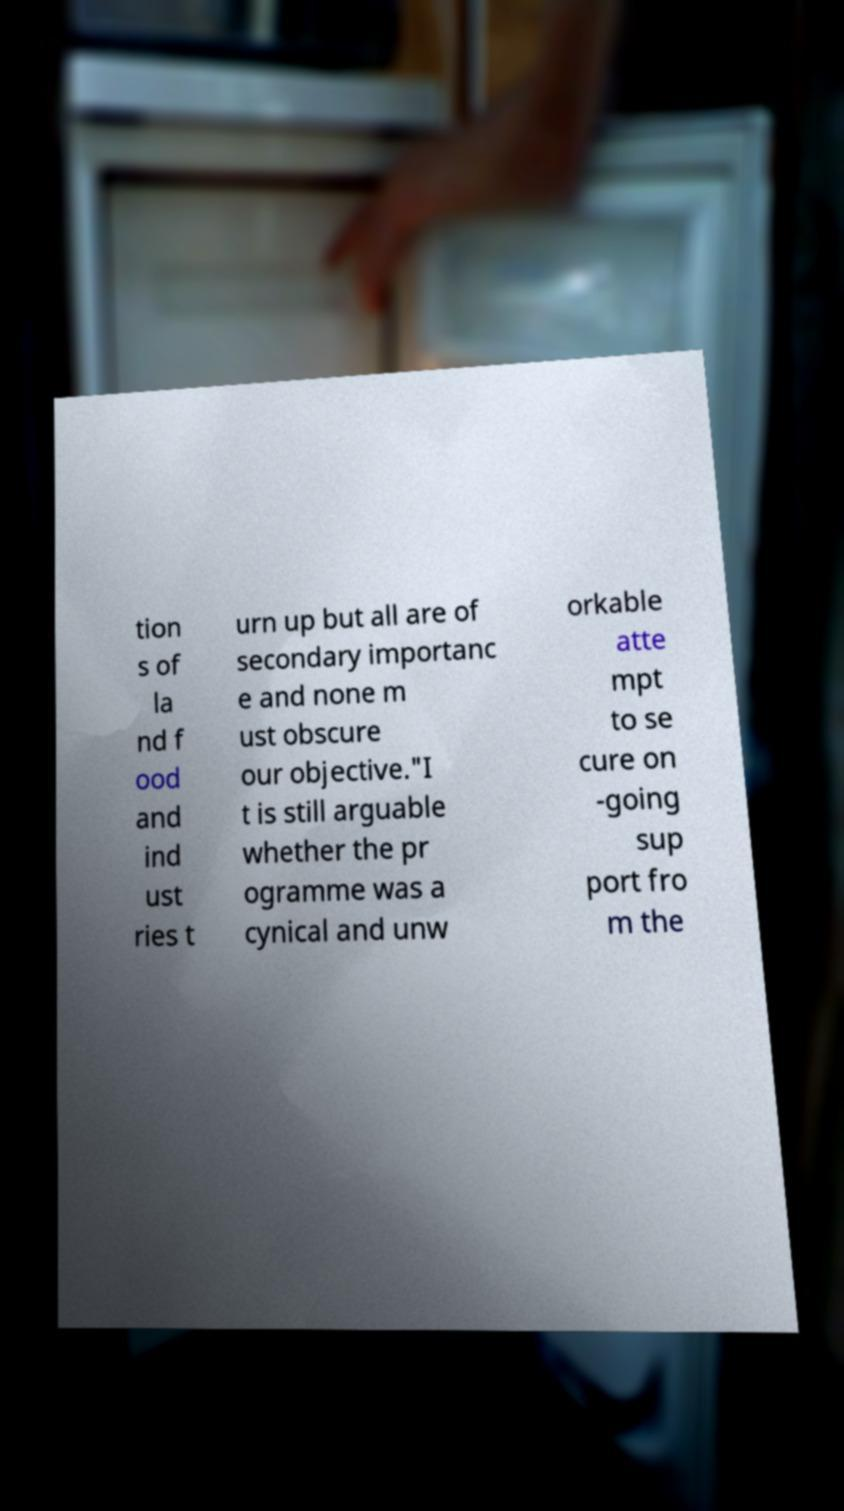Can you read and provide the text displayed in the image?This photo seems to have some interesting text. Can you extract and type it out for me? tion s of la nd f ood and ind ust ries t urn up but all are of secondary importanc e and none m ust obscure our objective."I t is still arguable whether the pr ogramme was a cynical and unw orkable atte mpt to se cure on -going sup port fro m the 